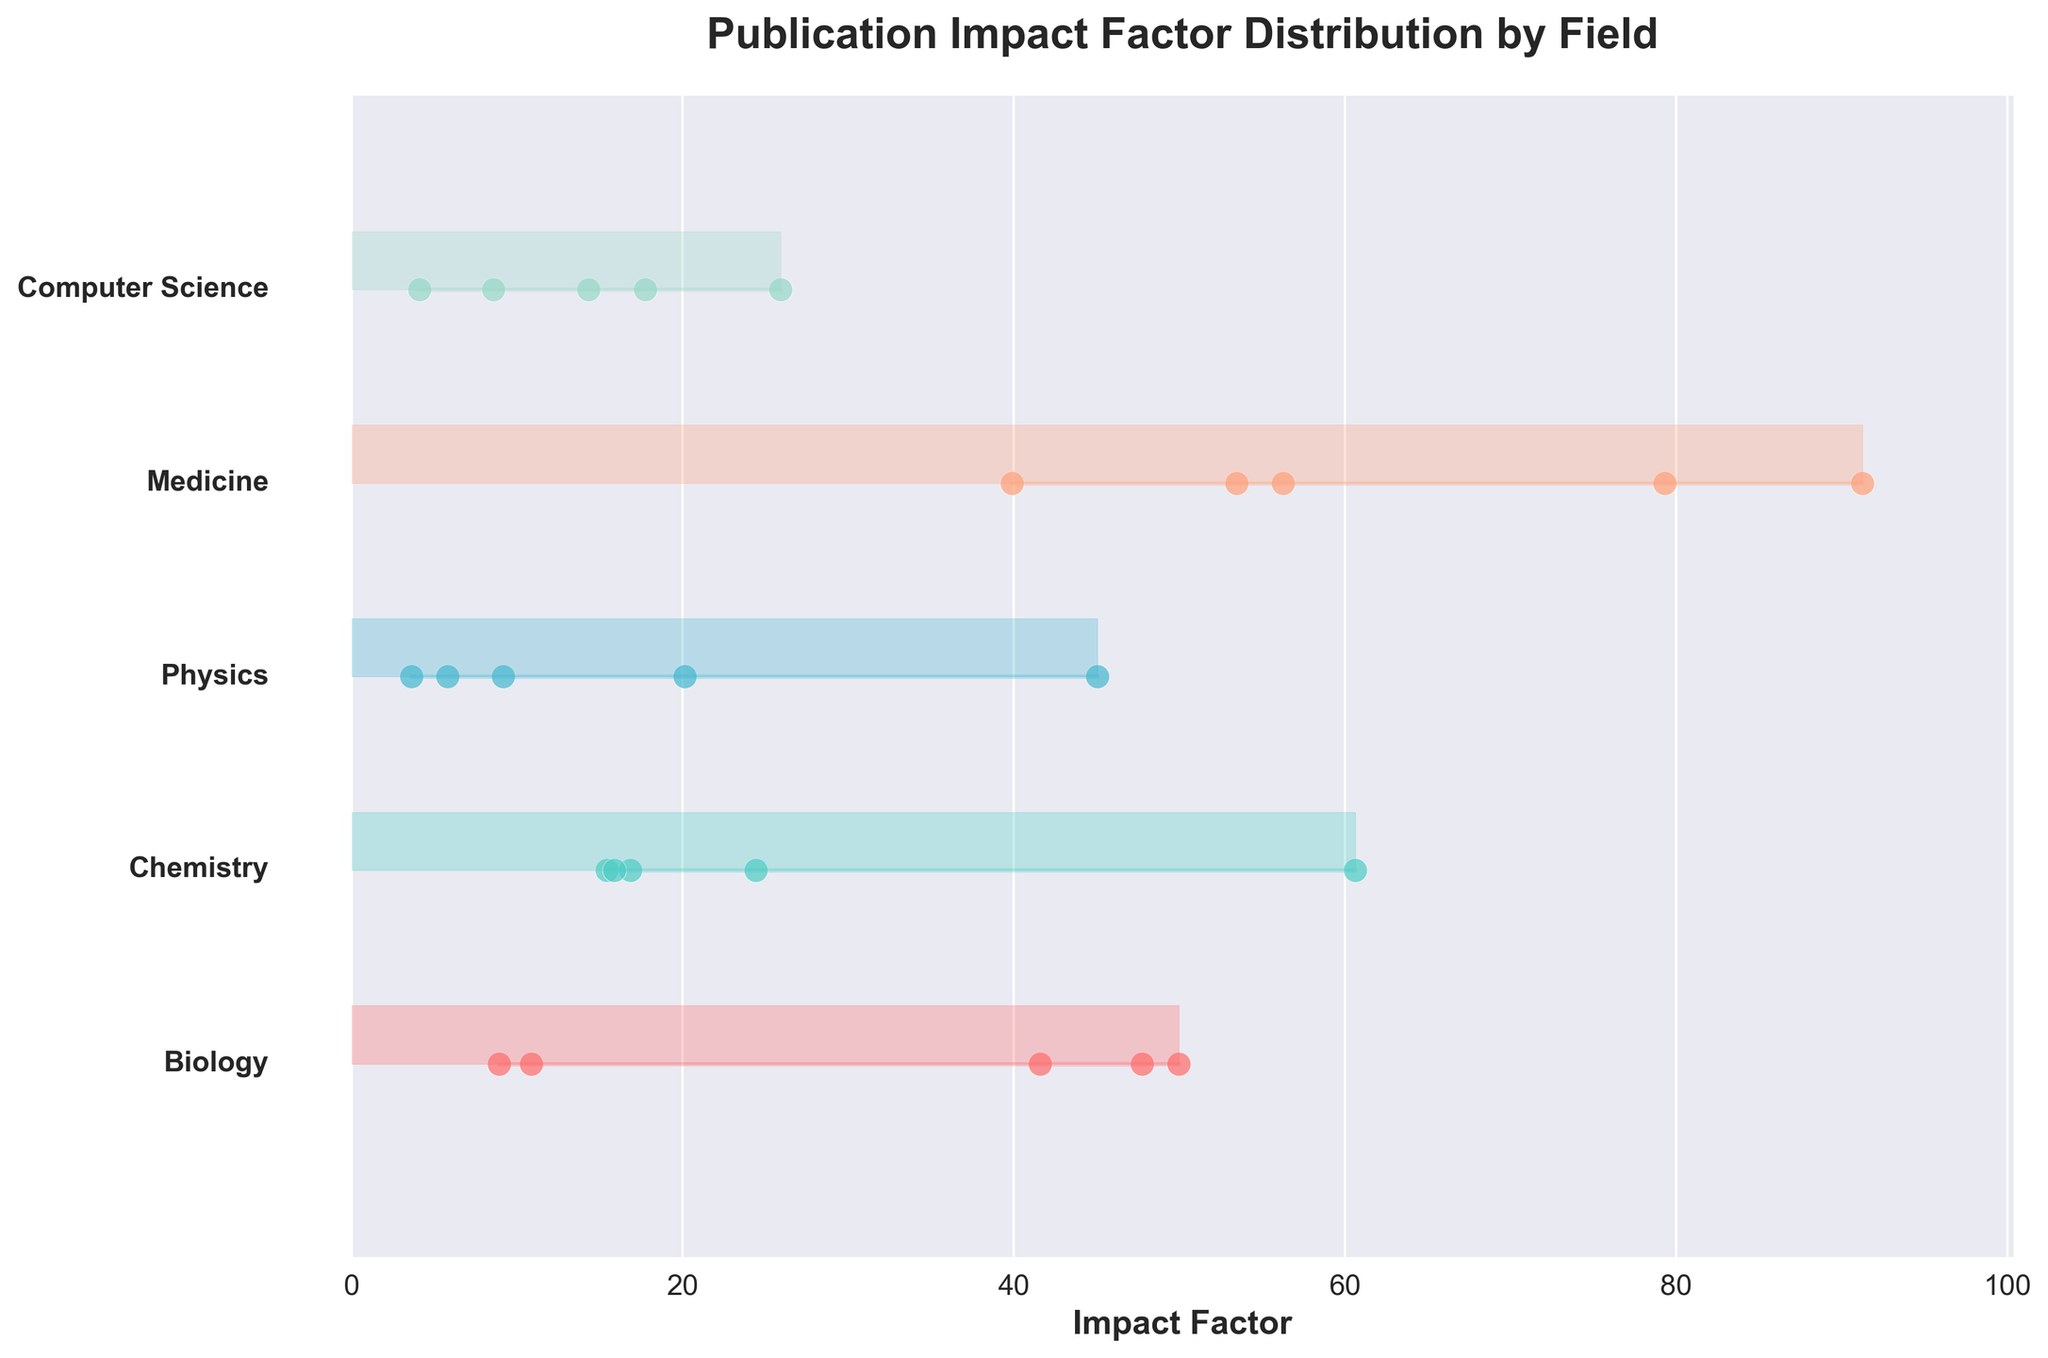what is the title of the plot? The title of the plot is usually written in a large bold font at the top of the figure.
Answer: Publication Impact Factor Distribution by Field How many fields of study are represented in the plot? The number of unique fields can be inferred by counting the distinct y-axis labels on the left side of the ridgeline plot.
Answer: 5 Which journal has the highest impact factor in Medicine? Identify the field "Medicine" and locate the scatter point with the highest x-value, then look at the corresponding label.
Answer: The New England Journal of Medicine Which field has the most diverse range of impact factors? Compare the spread of impact factors for each field by looking at the range of x-values that each field spans. The field with the largest range is the most diverse.
Answer: Medicine What's the average impact factor for journals in Computer Science? Sum the impact factors of journals in the Computer Science field and divide by the number of journals. (25.898 + 17.73 + 14.324 + 4.091 + 8.547) / 5 = 70.59 / 5 = 14.118
Answer: 14.118 What is the minimum impact factor for Physics journals? Find the field "Physics" and identify the scatter point representing the smallest x-value.
Answer: 3.597 Which has a greater impact factor, Nature or Science in Biology? Look at the scatter points under the field "Biology", find "Nature" and "Science", and compare their x-values.
Answer: Nature Among Medicine and Chemistry, which field has the highest journal impact factor? Compare the highest x-values in the scatter points of fields "Medicine" and "Chemistry".
Answer: Medicine Are there any fields where all journals have an impact factor below 10? Scan each field's scatter points to see if all x-values are below 10.
Answer: No 